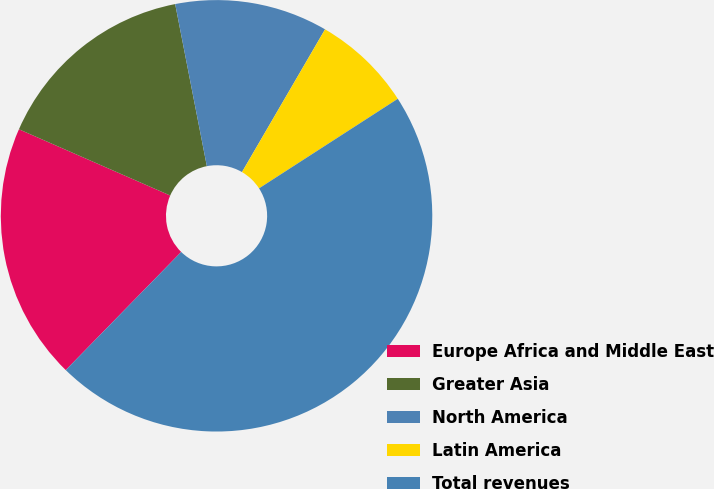<chart> <loc_0><loc_0><loc_500><loc_500><pie_chart><fcel>Europe Africa and Middle East<fcel>Greater Asia<fcel>North America<fcel>Latin America<fcel>Total revenues<nl><fcel>19.25%<fcel>15.36%<fcel>11.46%<fcel>7.49%<fcel>46.44%<nl></chart> 